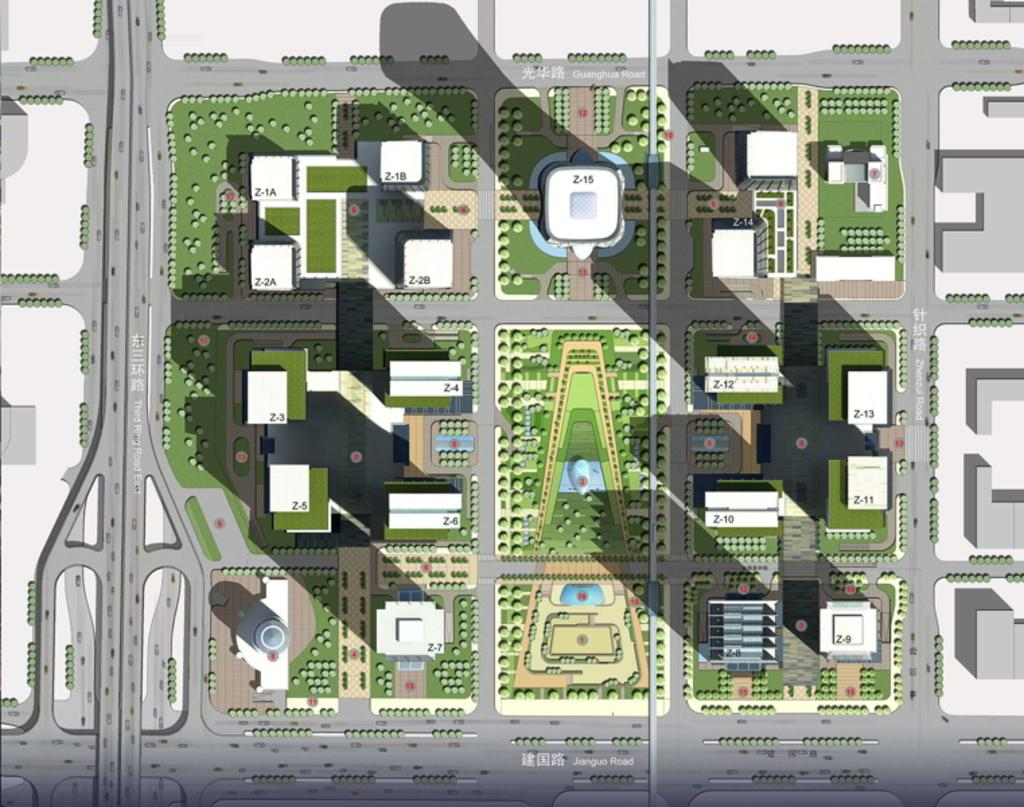What type of structures can be seen in the image? The image contains buildings. What type of transportation infrastructure is present in the image? The image contains roads. What type of natural elements can be seen in the image? The image contains plants. What type of collar can be seen on the beginner in the image? There is no beginner or collar present in the image. What causes the plants to laugh in the image? Plants do not have the ability to laugh, and there is no indication of laughter in the image. 